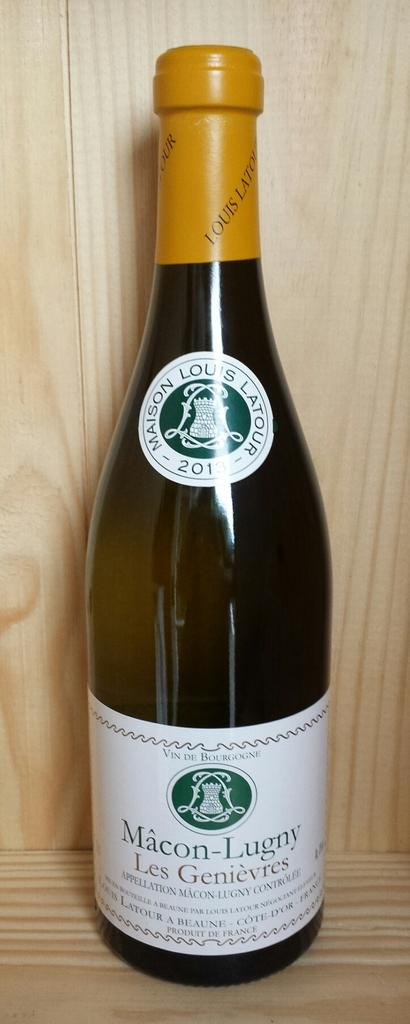<image>
Relay a brief, clear account of the picture shown. A bottle of wine that says Les Genievres. 